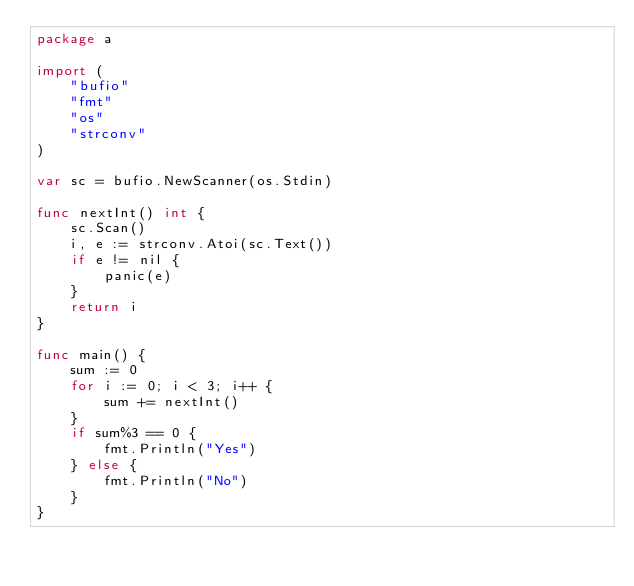Convert code to text. <code><loc_0><loc_0><loc_500><loc_500><_Go_>package a

import (
	"bufio"
	"fmt"
	"os"
	"strconv"
)

var sc = bufio.NewScanner(os.Stdin)

func nextInt() int {
	sc.Scan()
	i, e := strconv.Atoi(sc.Text())
	if e != nil {
		panic(e)
	}
	return i
}

func main() {
	sum := 0
	for i := 0; i < 3; i++ {
		sum += nextInt()
	}
	if sum%3 == 0 {
		fmt.Println("Yes")
	} else {
		fmt.Println("No")
	}
}
</code> 